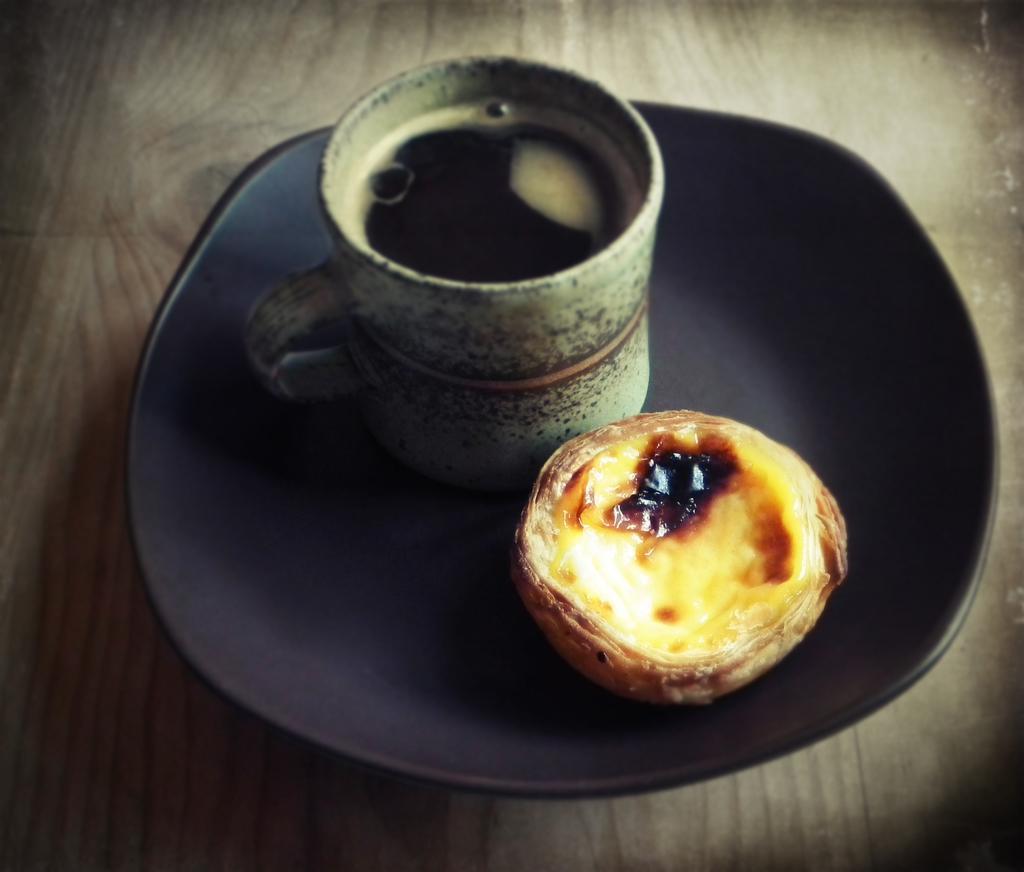Could you give a brief overview of what you see in this image? In this image we can see liquid in a cup and a food item in the plate on a platform. 